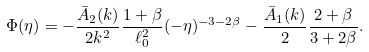Convert formula to latex. <formula><loc_0><loc_0><loc_500><loc_500>\Phi ( \eta ) = - \frac { \bar { A } _ { 2 } ( k ) } { 2 k ^ { 2 } } \frac { 1 + \beta } { \ell _ { 0 } ^ { 2 } } ( - \eta ) ^ { - 3 - 2 \beta } - \frac { \bar { A } _ { 1 } ( k ) } { 2 } \frac { 2 + \beta } { 3 + 2 \beta } .</formula> 